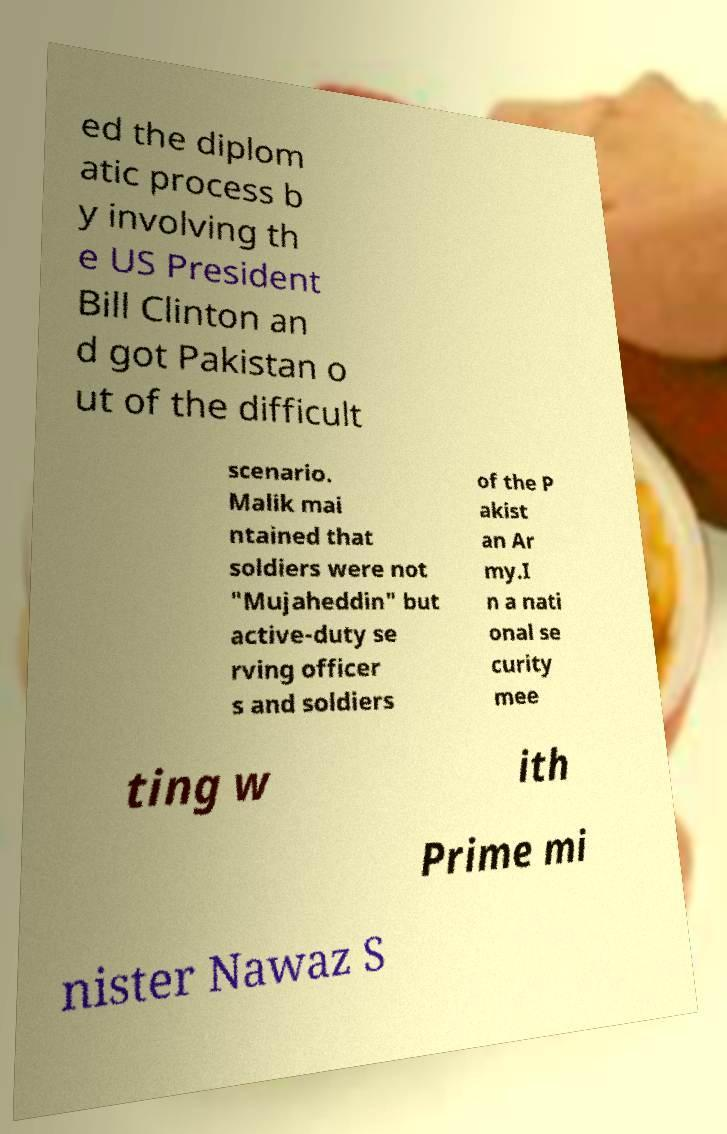Please read and relay the text visible in this image. What does it say? ed the diplom atic process b y involving th e US President Bill Clinton an d got Pakistan o ut of the difficult scenario. Malik mai ntained that soldiers were not "Mujaheddin" but active-duty se rving officer s and soldiers of the P akist an Ar my.I n a nati onal se curity mee ting w ith Prime mi nister Nawaz S 